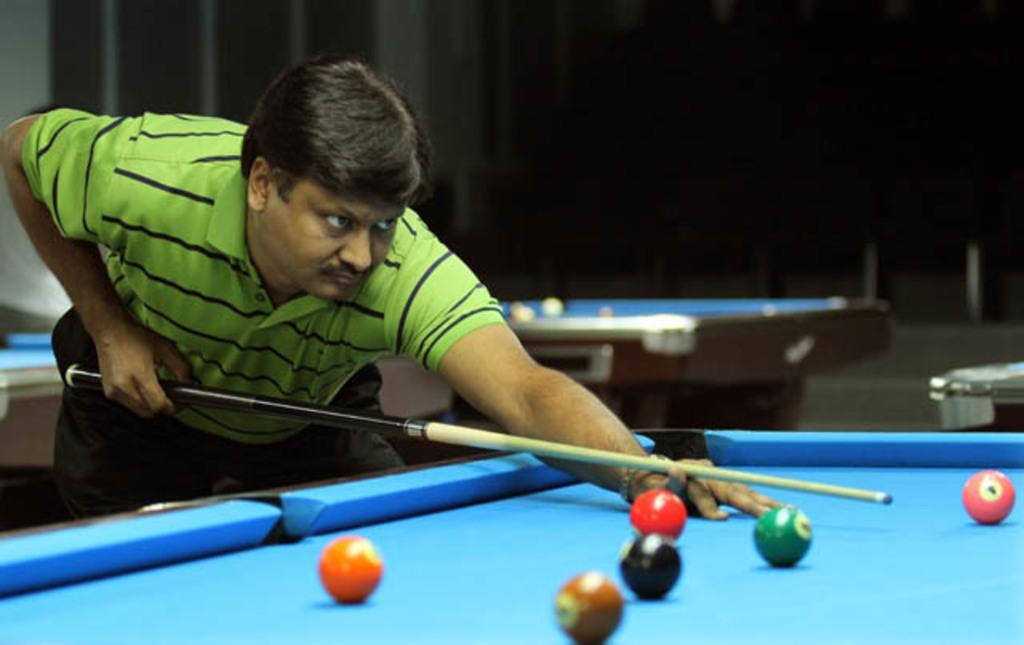Please provide a concise description of this image. In this image i can see a person holding a stick in his hands, I can see a table and balls in it. In the background i can see another table. 